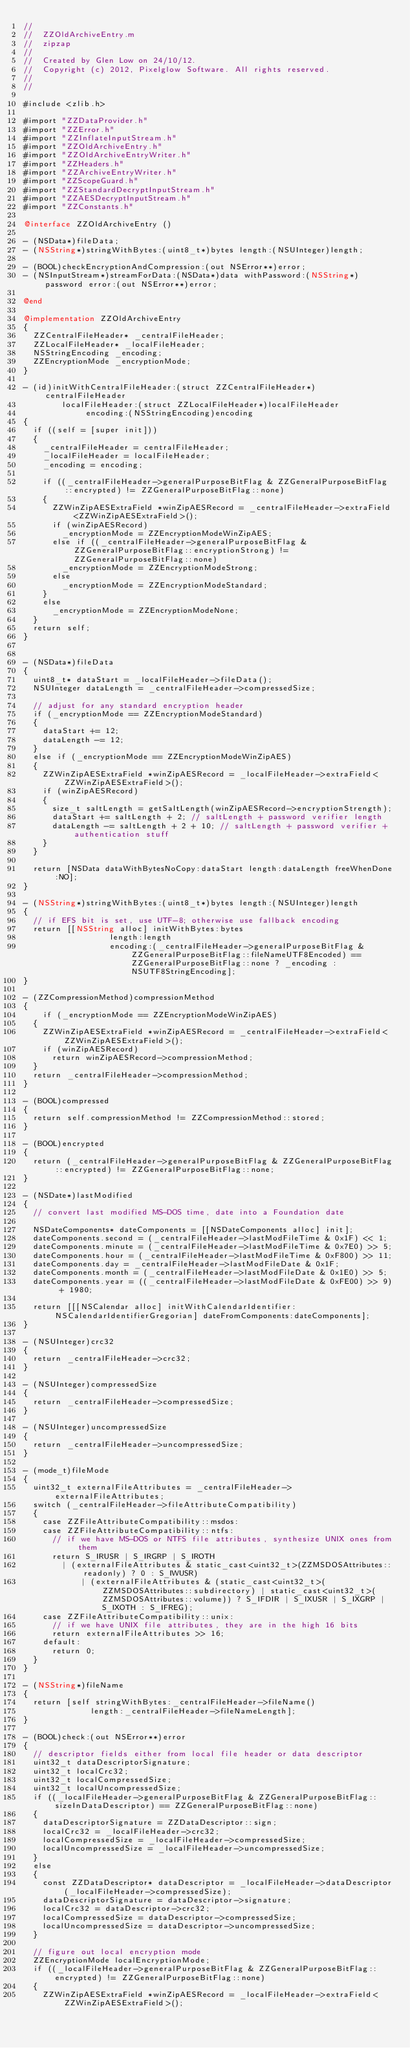Convert code to text. <code><loc_0><loc_0><loc_500><loc_500><_ObjectiveC_>//
//  ZZOldArchiveEntry.m
//  zipzap
//
//  Created by Glen Low on 24/10/12.
//  Copyright (c) 2012, Pixelglow Software. All rights reserved.
//
//

#include <zlib.h>

#import "ZZDataProvider.h"
#import "ZZError.h"
#import "ZZInflateInputStream.h"
#import "ZZOldArchiveEntry.h"
#import "ZZOldArchiveEntryWriter.h"
#import "ZZHeaders.h"
#import "ZZArchiveEntryWriter.h"
#import "ZZScopeGuard.h"
#import "ZZStandardDecryptInputStream.h"
#import "ZZAESDecryptInputStream.h"
#import "ZZConstants.h"

@interface ZZOldArchiveEntry ()

- (NSData*)fileData;
- (NSString*)stringWithBytes:(uint8_t*)bytes length:(NSUInteger)length;

- (BOOL)checkEncryptionAndCompression:(out NSError**)error;
- (NSInputStream*)streamForData:(NSData*)data withPassword:(NSString*)password error:(out NSError**)error;

@end

@implementation ZZOldArchiveEntry
{
	ZZCentralFileHeader* _centralFileHeader;
	ZZLocalFileHeader* _localFileHeader;
	NSStringEncoding _encoding;
	ZZEncryptionMode _encryptionMode;
}

- (id)initWithCentralFileHeader:(struct ZZCentralFileHeader*)centralFileHeader
				localFileHeader:(struct ZZLocalFileHeader*)localFileHeader
					   encoding:(NSStringEncoding)encoding
{
	if ((self = [super init]))
	{
		_centralFileHeader = centralFileHeader;
		_localFileHeader = localFileHeader;
		_encoding = encoding;
		
		if ((_centralFileHeader->generalPurposeBitFlag & ZZGeneralPurposeBitFlag::encrypted) != ZZGeneralPurposeBitFlag::none)
		{
			ZZWinZipAESExtraField *winZipAESRecord = _centralFileHeader->extraField<ZZWinZipAESExtraField>();
			if (winZipAESRecord)
				_encryptionMode = ZZEncryptionModeWinZipAES;
			else if ((_centralFileHeader->generalPurposeBitFlag & ZZGeneralPurposeBitFlag::encryptionStrong) != ZZGeneralPurposeBitFlag::none)
				_encryptionMode = ZZEncryptionModeStrong;
			else
				_encryptionMode = ZZEncryptionModeStandard;
		}
		else
			_encryptionMode = ZZEncryptionModeNone;
	}
	return self;
}


- (NSData*)fileData
{
	uint8_t* dataStart = _localFileHeader->fileData();
	NSUInteger dataLength = _centralFileHeader->compressedSize;
	
	// adjust for any standard encryption header
	if (_encryptionMode == ZZEncryptionModeStandard)
	{
		dataStart += 12;
		dataLength -= 12;
	}
	else if (_encryptionMode == ZZEncryptionModeWinZipAES)
	{
		ZZWinZipAESExtraField *winZipAESRecord = _localFileHeader->extraField<ZZWinZipAESExtraField>();
		if (winZipAESRecord)
		{
			size_t saltLength = getSaltLength(winZipAESRecord->encryptionStrength);
			dataStart += saltLength + 2; // saltLength + password verifier length
			dataLength -= saltLength + 2 + 10; // saltLength + password verifier + authentication stuff
		}
	}

	return [NSData dataWithBytesNoCopy:dataStart length:dataLength freeWhenDone:NO];
}

- (NSString*)stringWithBytes:(uint8_t*)bytes length:(NSUInteger)length
{
	// if EFS bit is set, use UTF-8; otherwise use fallback encoding
	return [[NSString alloc] initWithBytes:bytes
									length:length
								  encoding:(_centralFileHeader->generalPurposeBitFlag & ZZGeneralPurposeBitFlag::fileNameUTF8Encoded) == ZZGeneralPurposeBitFlag::none ? _encoding :NSUTF8StringEncoding];
}

- (ZZCompressionMethod)compressionMethod
{
    if (_encryptionMode == ZZEncryptionModeWinZipAES)
	{
		ZZWinZipAESExtraField *winZipAESRecord = _centralFileHeader->extraField<ZZWinZipAESExtraField>();
		if (winZipAESRecord)
			return winZipAESRecord->compressionMethod;
	}
	return _centralFileHeader->compressionMethod;
}

- (BOOL)compressed
{
	return self.compressionMethod != ZZCompressionMethod::stored;
}

- (BOOL)encrypted
{
	return (_centralFileHeader->generalPurposeBitFlag & ZZGeneralPurposeBitFlag::encrypted) != ZZGeneralPurposeBitFlag::none;
}

- (NSDate*)lastModified
{
	// convert last modified MS-DOS time, date into a Foundation date
	
	NSDateComponents* dateComponents = [[NSDateComponents alloc] init];
	dateComponents.second = (_centralFileHeader->lastModFileTime & 0x1F) << 1;
	dateComponents.minute = (_centralFileHeader->lastModFileTime & 0x7E0) >> 5;
	dateComponents.hour = (_centralFileHeader->lastModFileTime & 0xF800) >> 11;
	dateComponents.day = _centralFileHeader->lastModFileDate & 0x1F;
	dateComponents.month = (_centralFileHeader->lastModFileDate & 0x1E0) >> 5;
	dateComponents.year = ((_centralFileHeader->lastModFileDate & 0xFE00) >> 9) + 1980;
	
	return [[[NSCalendar alloc] initWithCalendarIdentifier:NSCalendarIdentifierGregorian] dateFromComponents:dateComponents];
}

- (NSUInteger)crc32
{
	return _centralFileHeader->crc32;
}

- (NSUInteger)compressedSize
{
	return _centralFileHeader->compressedSize;
}

- (NSUInteger)uncompressedSize
{
	return _centralFileHeader->uncompressedSize;
}

- (mode_t)fileMode
{
	uint32_t externalFileAttributes = _centralFileHeader->externalFileAttributes;
	switch (_centralFileHeader->fileAttributeCompatibility)
	{
		case ZZFileAttributeCompatibility::msdos:
		case ZZFileAttributeCompatibility::ntfs:
			// if we have MS-DOS or NTFS file attributes, synthesize UNIX ones from them
			return S_IRUSR | S_IRGRP | S_IROTH
				| (externalFileAttributes & static_cast<uint32_t>(ZZMSDOSAttributes::readonly) ? 0 : S_IWUSR)
            | (externalFileAttributes & (static_cast<uint32_t>(ZZMSDOSAttributes::subdirectory) | static_cast<uint32_t>(ZZMSDOSAttributes::volume)) ? S_IFDIR | S_IXUSR | S_IXGRP | S_IXOTH : S_IFREG);
		case ZZFileAttributeCompatibility::unix:
			// if we have UNIX file attributes, they are in the high 16 bits
			return externalFileAttributes >> 16;
		default:
			return 0;
	}
}

- (NSString*)fileName
{
	return [self stringWithBytes:_centralFileHeader->fileName()
						  length:_centralFileHeader->fileNameLength];
}

- (BOOL)check:(out NSError**)error
{
	// descriptor fields either from local file header or data descriptor
	uint32_t dataDescriptorSignature;
	uint32_t localCrc32;
	uint32_t localCompressedSize;
	uint32_t localUncompressedSize;
	if ((_localFileHeader->generalPurposeBitFlag & ZZGeneralPurposeBitFlag::sizeInDataDescriptor) == ZZGeneralPurposeBitFlag::none)
	{
		dataDescriptorSignature = ZZDataDescriptor::sign;
		localCrc32 = _localFileHeader->crc32;
		localCompressedSize = _localFileHeader->compressedSize;
		localUncompressedSize = _localFileHeader->uncompressedSize;
	}
	else
	{
		const ZZDataDescriptor* dataDescriptor = _localFileHeader->dataDescriptor(_localFileHeader->compressedSize);
		dataDescriptorSignature = dataDescriptor->signature;
		localCrc32 = dataDescriptor->crc32;
		localCompressedSize = dataDescriptor->compressedSize;
		localUncompressedSize = dataDescriptor->uncompressedSize;
	}
	
	// figure out local encryption mode
	ZZEncryptionMode localEncryptionMode;
	if ((_localFileHeader->generalPurposeBitFlag & ZZGeneralPurposeBitFlag::encrypted) != ZZGeneralPurposeBitFlag::none)
	{
		ZZWinZipAESExtraField *winZipAESRecord = _localFileHeader->extraField<ZZWinZipAESExtraField>();
		</code> 